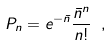<formula> <loc_0><loc_0><loc_500><loc_500>P _ { n } = e ^ { - \bar { n } } \frac { \bar { n } ^ { n } } { n ! } \ ,</formula> 